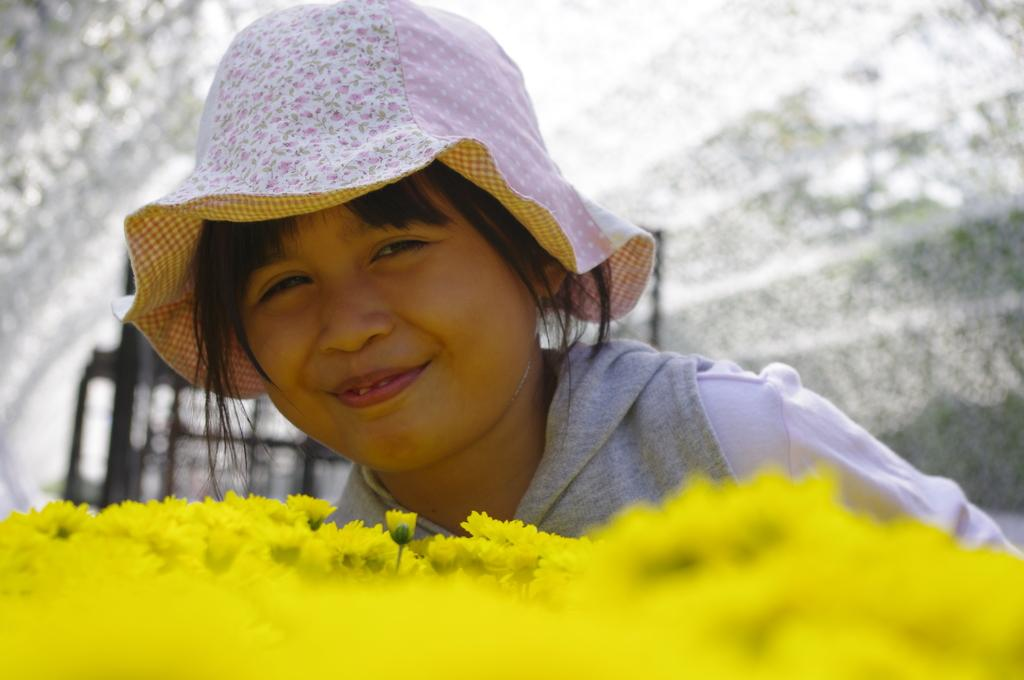What type of flowers can be seen in the foreground of the image? There are yellow colored flowers in the foreground of the image. Who is present in the image? There is a girl in the image. What is the girl wearing on her head? The girl is wearing a hat. What is the girl's facial expression in the image? The girl has a smile on her face. How would you describe the background of the image? The background of the image is blurred. What type of truck can be seen in the background of the image? There is no truck present in the image; the background is blurred. Is there a gate visible in the image? There is no gate present in the image; the focus is on the girl and the yellow flowers. 